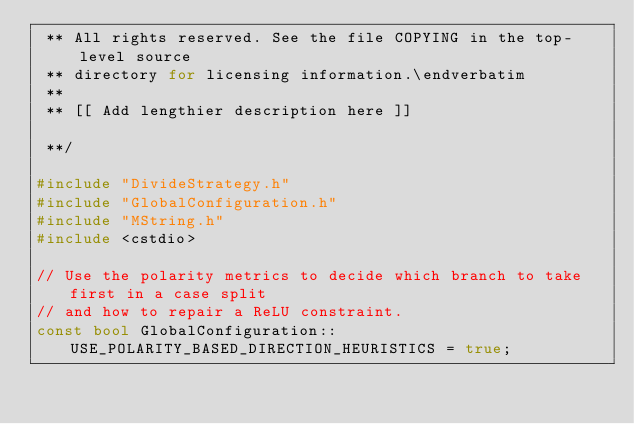<code> <loc_0><loc_0><loc_500><loc_500><_C++_> ** All rights reserved. See the file COPYING in the top-level source
 ** directory for licensing information.\endverbatim
 **
 ** [[ Add lengthier description here ]]

 **/

#include "DivideStrategy.h"
#include "GlobalConfiguration.h"
#include "MString.h"
#include <cstdio>

// Use the polarity metrics to decide which branch to take first in a case split
// and how to repair a ReLU constraint.
const bool GlobalConfiguration::USE_POLARITY_BASED_DIRECTION_HEURISTICS = true;
</code> 